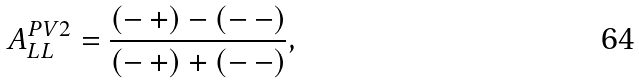Convert formula to latex. <formula><loc_0><loc_0><loc_500><loc_500>A _ { L L } ^ { P V 2 } = \frac { ( - \, + ) - ( - \, - ) } { ( - \, + ) + ( - \, - ) } ,</formula> 